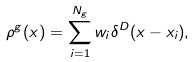<formula> <loc_0><loc_0><loc_500><loc_500>\rho ^ { g } ( x ) = \sum _ { i = 1 } ^ { N _ { g } } w _ { i } \delta ^ { D } ( x - x _ { i } ) ,</formula> 